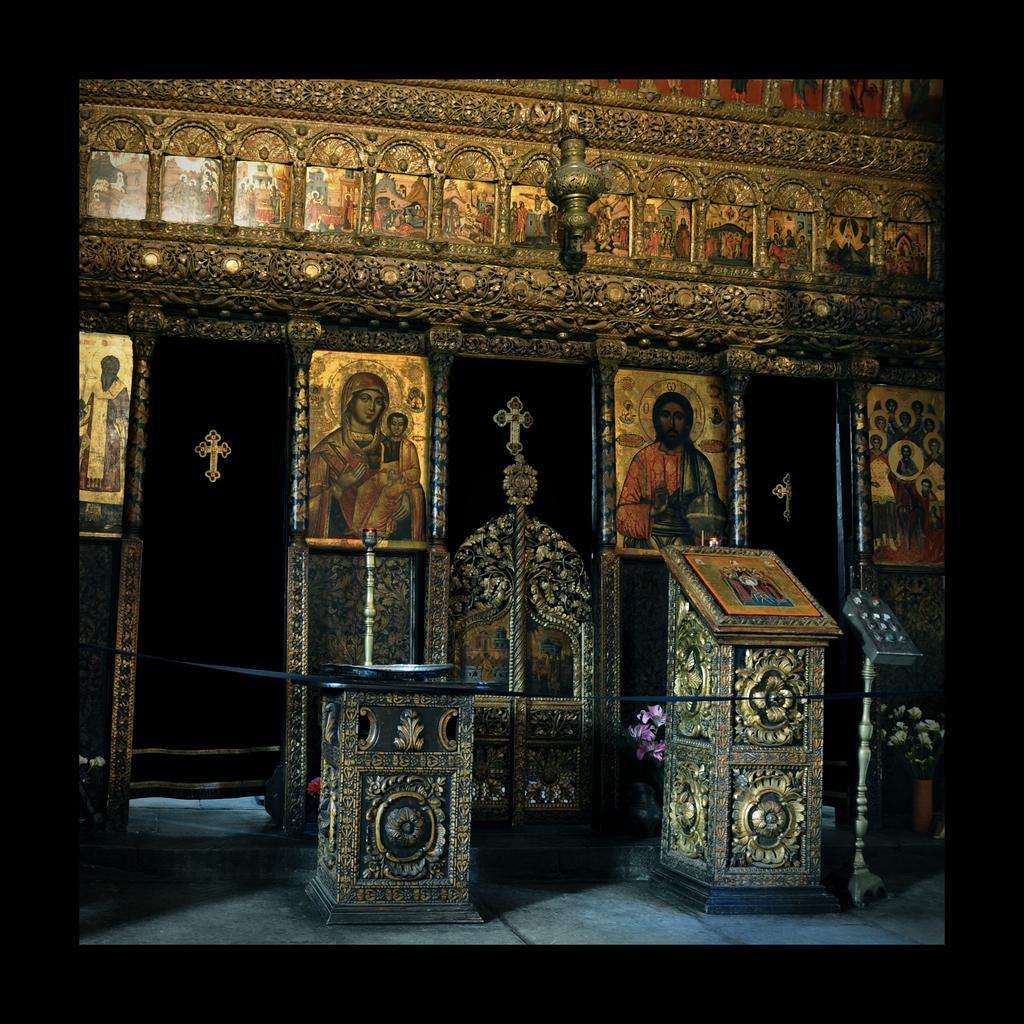Describe this image in one or two sentences. In this image we can see some photo frames on the wall, there is a podium, there are objects on the stand, there is an object is hung, and the borders are black in color. 